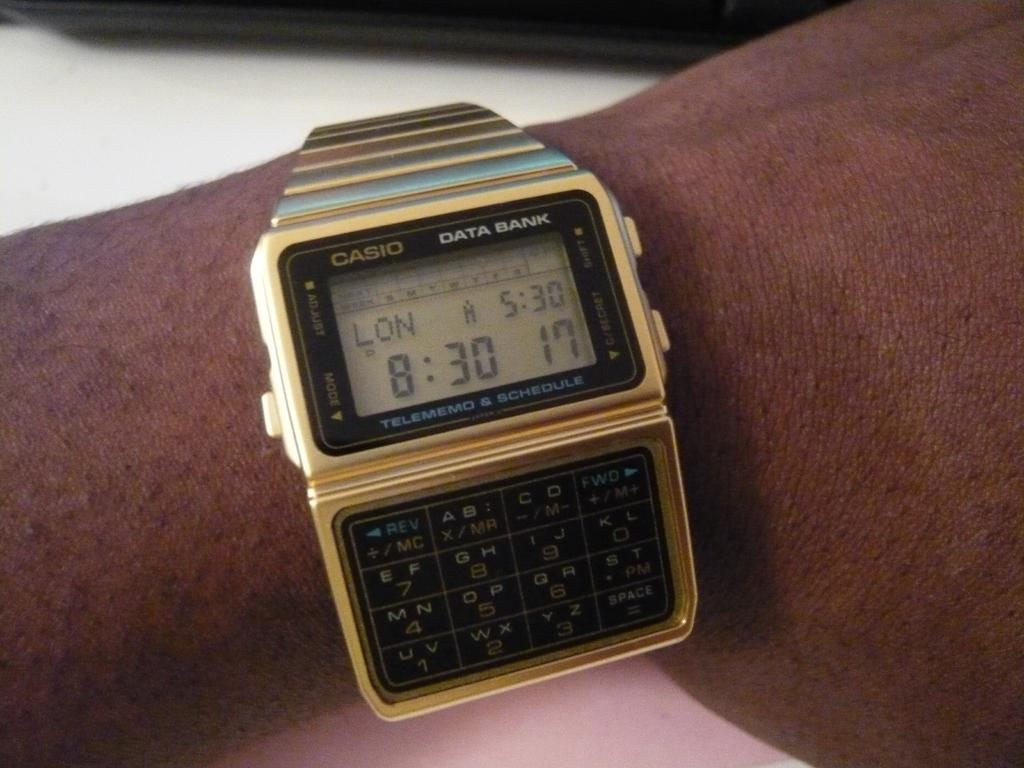Provide a one-sentence caption for the provided image. A Casio watch shows the time in London as well as the time in the current location. 